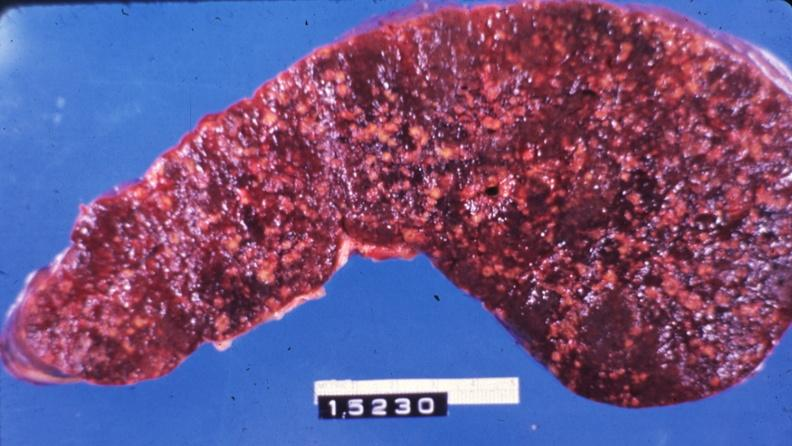what does this image show?
Answer the question using a single word or phrase. Slice of spleen with multiple nodules 